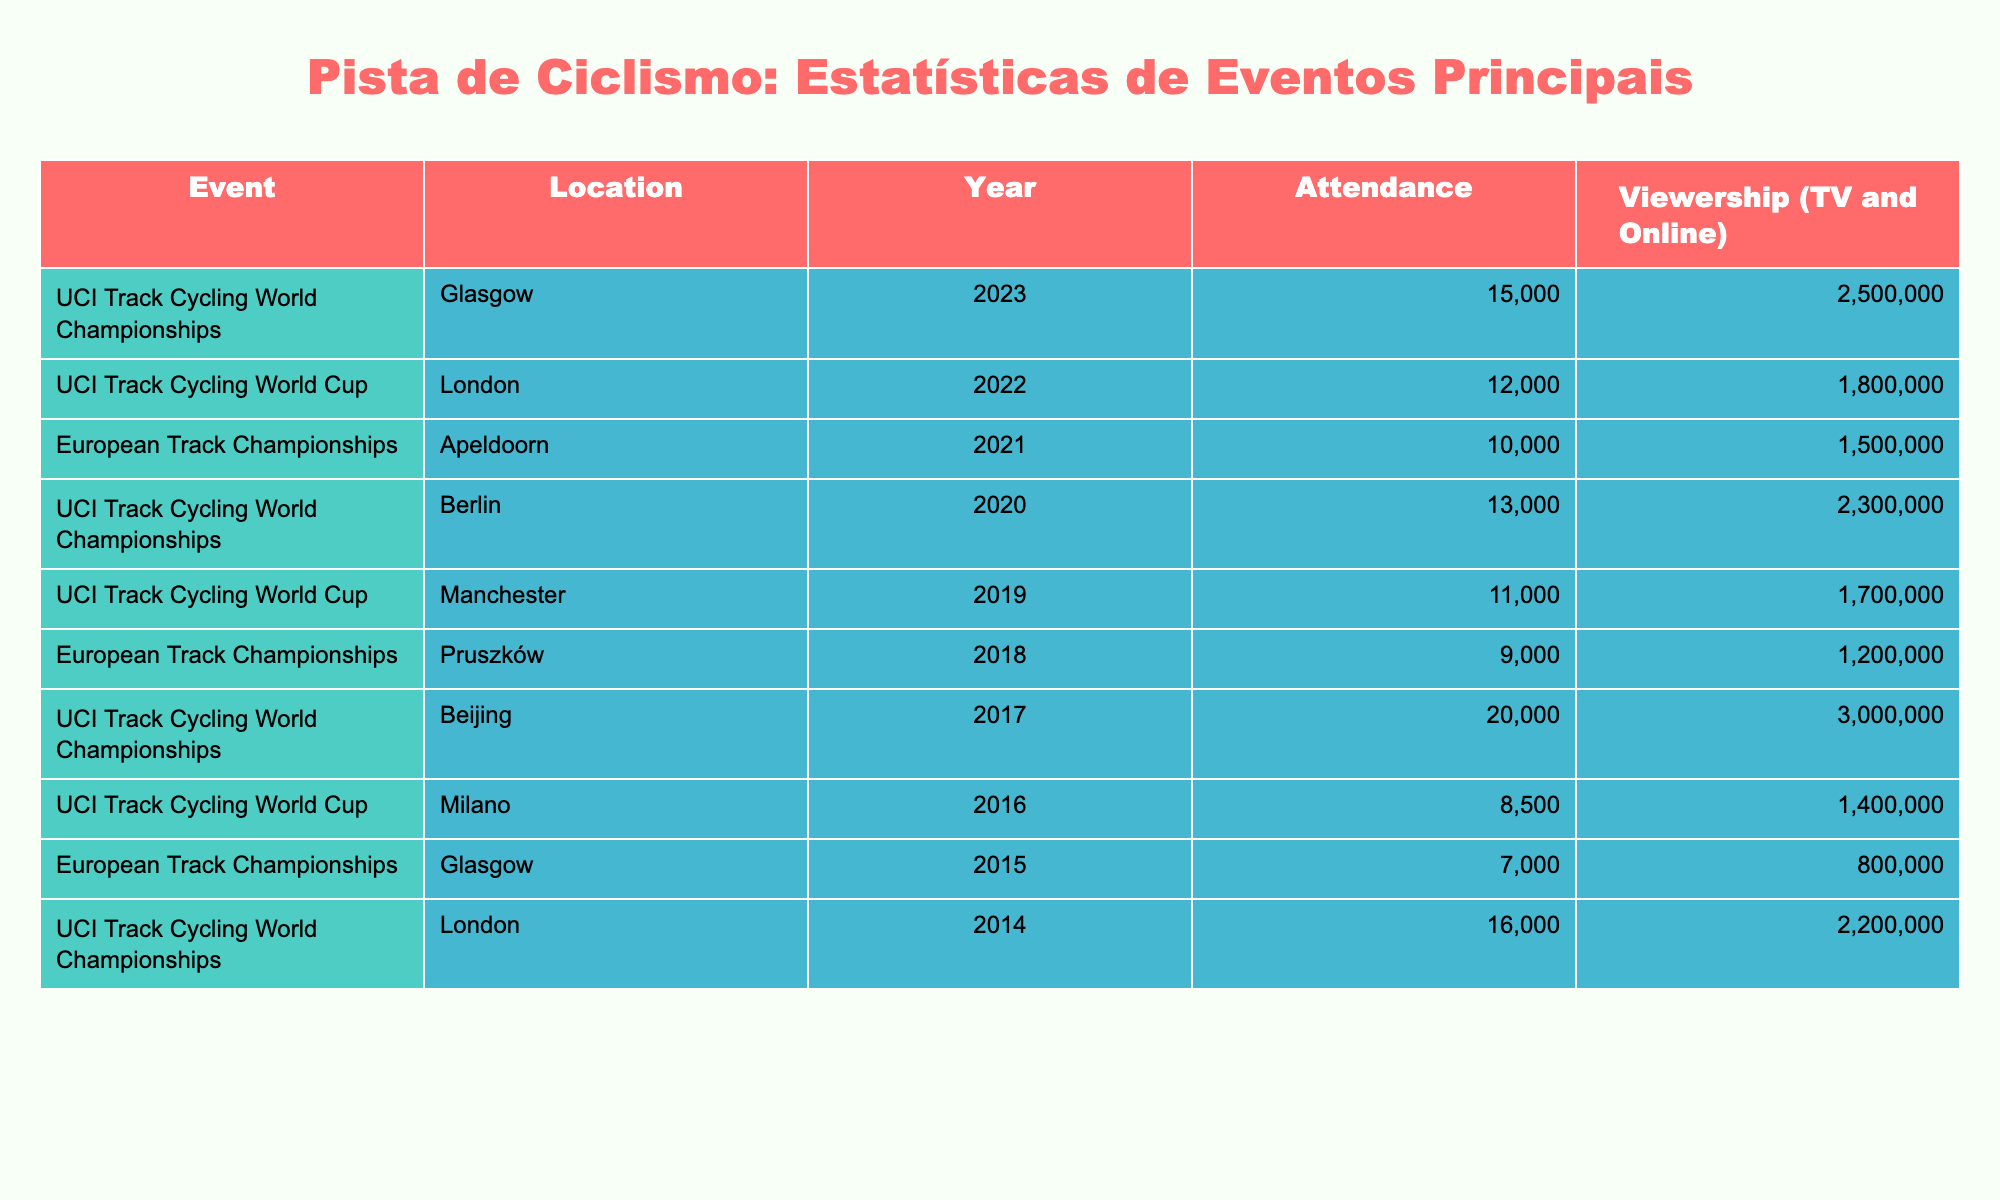What was the highest attendance recorded at any event in the table? The table shows attendance figures for several events; by scanning through, the highest value is 20,000 for the UCI Track Cycling World Championships in Beijing in 2017.
Answer: 20,000 Which event had the lowest viewership? Looking at the viewership numbers in the table, the lowest is 800,000 for the European Track Championships held in Glasgow in 2015.
Answer: 800,000 What is the total attendance across all events listed? To find the total attendance, we add the attendance figures: 15,000 + 12,000 + 10,000 + 13,000 + 11,000 + 9,000 + 20,000 + 8,500 + 7,000 + 16,000 = 171,500.
Answer: 171,500 Is the attendance for the UCI Track Cycling World Championships generally higher than for the European Track Championships? By comparing the attendance figures, we see that all recorded UCI Track Cycling World Championships have higher attendance than the European Track Championships events listed.
Answer: Yes What was the average viewership for the UCI Track Cycling World Cup events? The viewership numbers for the UCI Track Cycling World Cup events are 1,800,000 (2022) + 1,700,000 (2019) + 1,400,000 (2016) = 5,900,000. Dividing by 3 gives an average viewership of 1,966,667.
Answer: 1,966,667 What is the difference in attendance between the UCI Track Cycling World Championships in 2023 and 2014? The attendance for 2023 is 15,000 and for 2014 is 16,000. The difference is 16,000 - 15,000 = 1,000.
Answer: 1,000 Which location hosted the event with the second highest viewership? The event with the second highest viewership is the UCI Track Cycling World Championships in Berlin in 2020 with 2,300,000 viewers. Therefore, the location is Berlin.
Answer: Berlin Did the attendance at the European Track Championships in 2021 exceed 10,000? The table lists the attendance for the 2021 event at 10,000; since it is not greater than 10,000, the answer is no.
Answer: No How many events had an attendance greater than 10,000? By counting the figures, the events with attendance greater than 10,000 are: 2023 (15,000), 2022 (12,000), 2020 (13,000), 2014 (16,000), and 2017 (20,000), totaling 5 events.
Answer: 5 What percentage of the total attendance is represented by the event in Glasgow in 2023? The attendance in Glasgow in 2023 is 15,000, and the total attendance is 171,500. The percentage is (15,000 / 171,500) * 100, which is approximately 8.75%.
Answer: 8.75% 